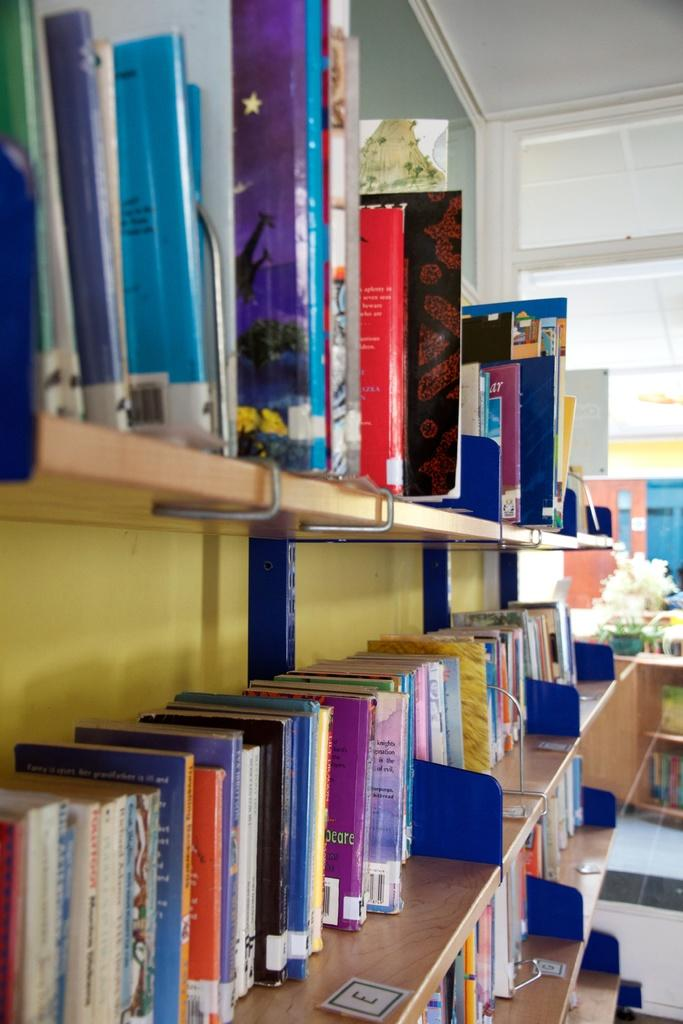What type of storage is shown in the image? There are wooden racks in the image. What are the wooden racks used for? The wooden racks contain many books. What can be seen on a table in the background of the image? There is a flower pot on a table in the background of the image. What is visible at the top of the image? The ceiling is visible at the top of the image. How many kites are being flown by the people in the image? There are no kites or people visible in the image; it only shows wooden racks with books, a flower pot on a table, and a ceiling. 